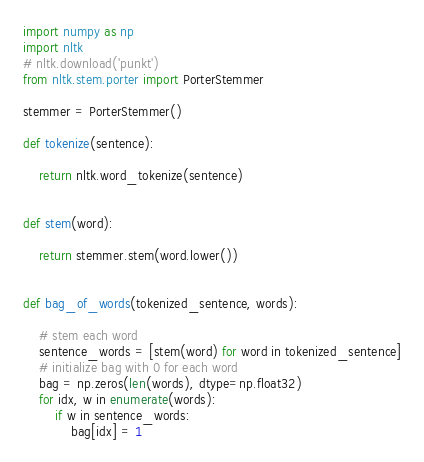Convert code to text. <code><loc_0><loc_0><loc_500><loc_500><_Python_>import numpy as np
import nltk
# nltk.download('punkt')
from nltk.stem.porter import PorterStemmer

stemmer = PorterStemmer()

def tokenize(sentence):

    return nltk.word_tokenize(sentence)


def stem(word):

    return stemmer.stem(word.lower())


def bag_of_words(tokenized_sentence, words):

    # stem each word
    sentence_words = [stem(word) for word in tokenized_sentence]
    # initialize bag with 0 for each word
    bag = np.zeros(len(words), dtype=np.float32)
    for idx, w in enumerate(words):
        if w in sentence_words: 
            bag[idx] = 1
</code> 